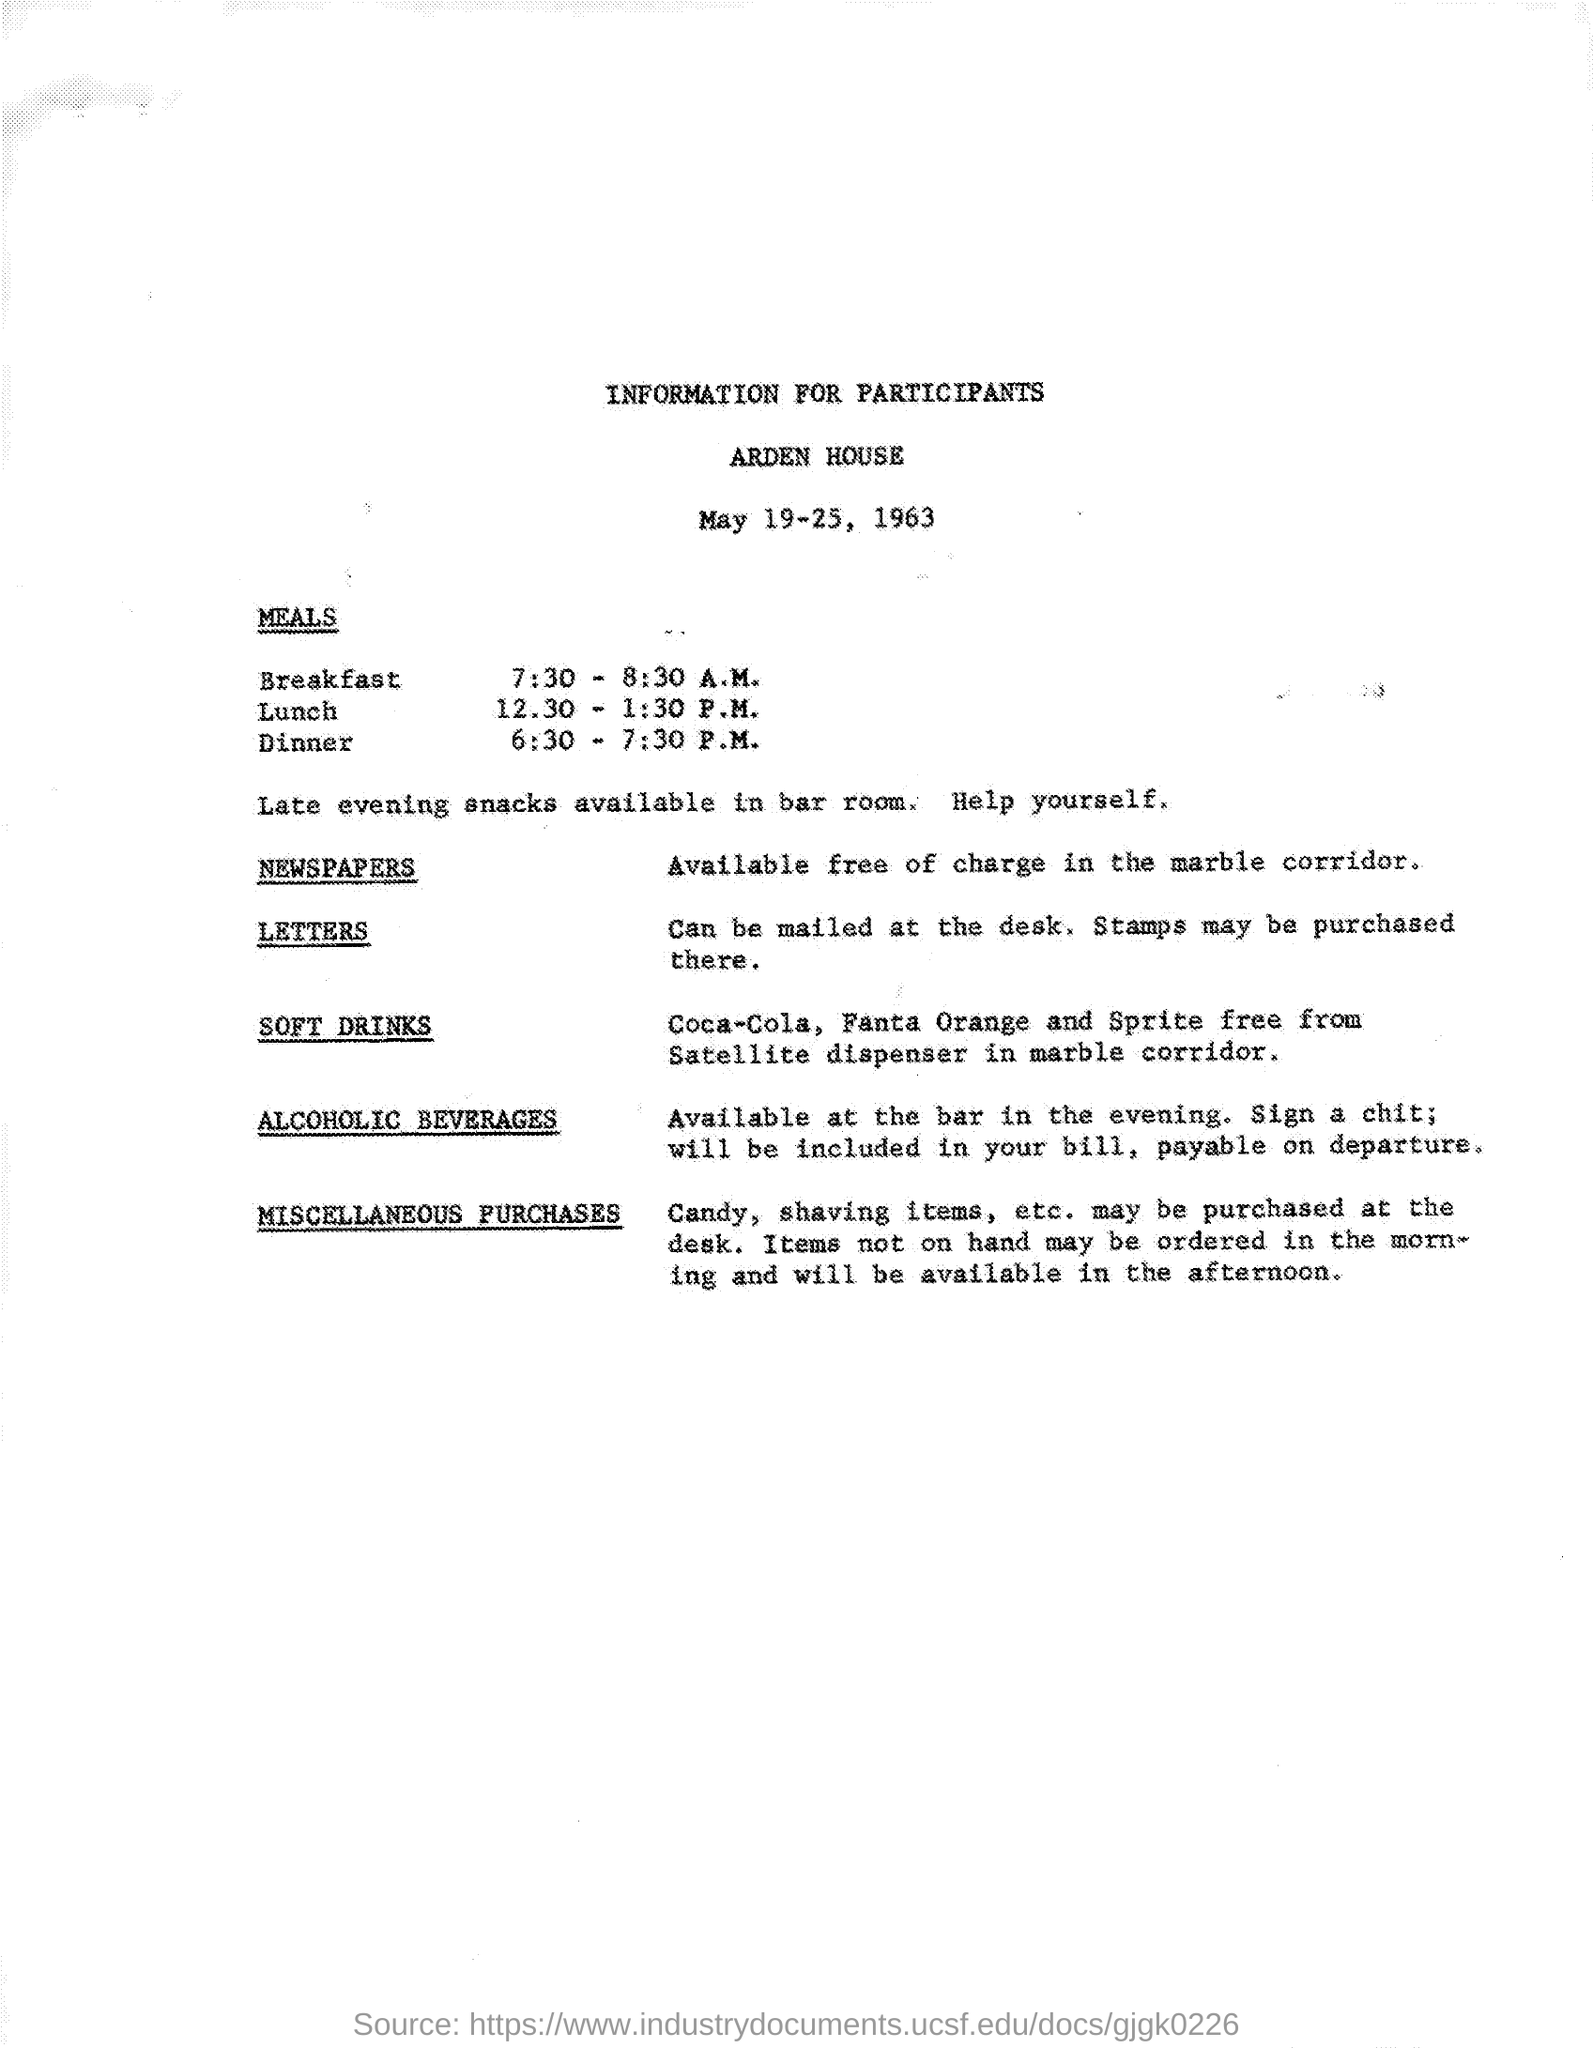Mention a couple of crucial points in this snapshot. The document indicates that the date range of May 19-25, 1963, is of relevance. 